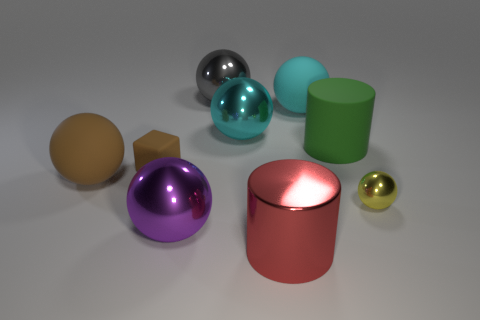Are there any other things that have the same material as the large brown sphere?
Provide a short and direct response. Yes. Is the size of the block the same as the matte ball that is on the right side of the metallic cylinder?
Give a very brief answer. No. What is the material of the tiny thing right of the big metallic ball in front of the small yellow ball?
Keep it short and to the point. Metal. Is the number of large red cylinders to the left of the brown sphere the same as the number of small green balls?
Give a very brief answer. Yes. What is the size of the object that is both left of the big gray metallic thing and in front of the big brown ball?
Provide a short and direct response. Large. The big object that is left of the brown rubber object on the right side of the large brown thing is what color?
Give a very brief answer. Brown. Are there an equal number of small cyan rubber spheres and large cyan metallic things?
Provide a short and direct response. No. How many purple things are either large rubber cylinders or large metallic spheres?
Offer a terse response. 1. There is a metal sphere that is both to the right of the gray shiny ball and on the left side of the small yellow sphere; what color is it?
Make the answer very short. Cyan. What number of large things are either rubber balls or blue spheres?
Give a very brief answer. 2. 